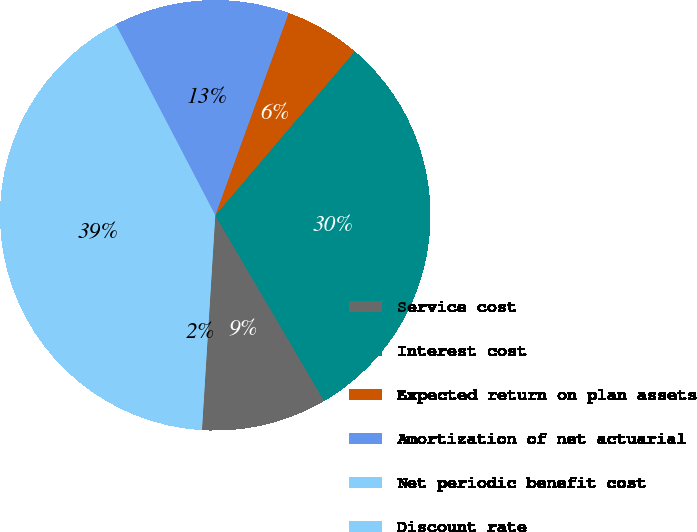<chart> <loc_0><loc_0><loc_500><loc_500><pie_chart><fcel>Service cost<fcel>Interest cost<fcel>Expected return on plan assets<fcel>Amortization of net actuarial<fcel>Net periodic benefit cost<fcel>Discount rate<nl><fcel>9.43%<fcel>30.33%<fcel>5.68%<fcel>13.18%<fcel>39.43%<fcel>1.93%<nl></chart> 